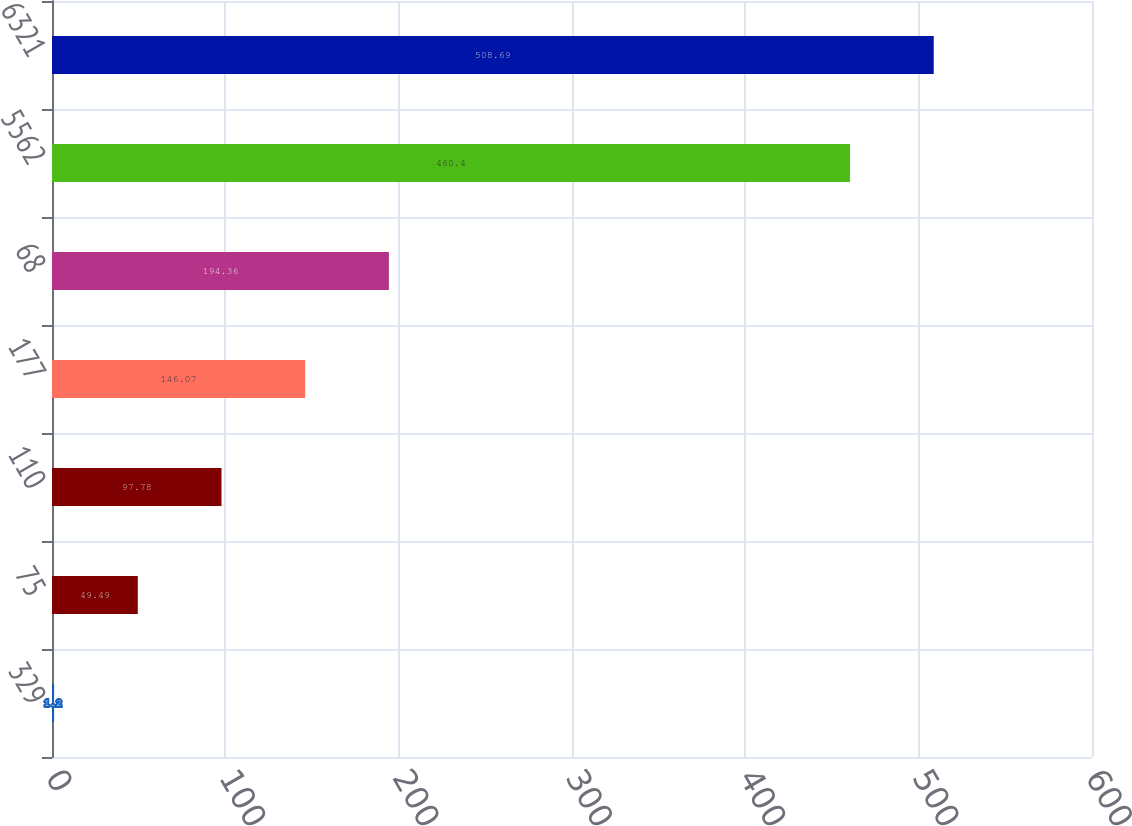<chart> <loc_0><loc_0><loc_500><loc_500><bar_chart><fcel>329<fcel>75<fcel>110<fcel>177<fcel>68<fcel>5562<fcel>6321<nl><fcel>1.2<fcel>49.49<fcel>97.78<fcel>146.07<fcel>194.36<fcel>460.4<fcel>508.69<nl></chart> 